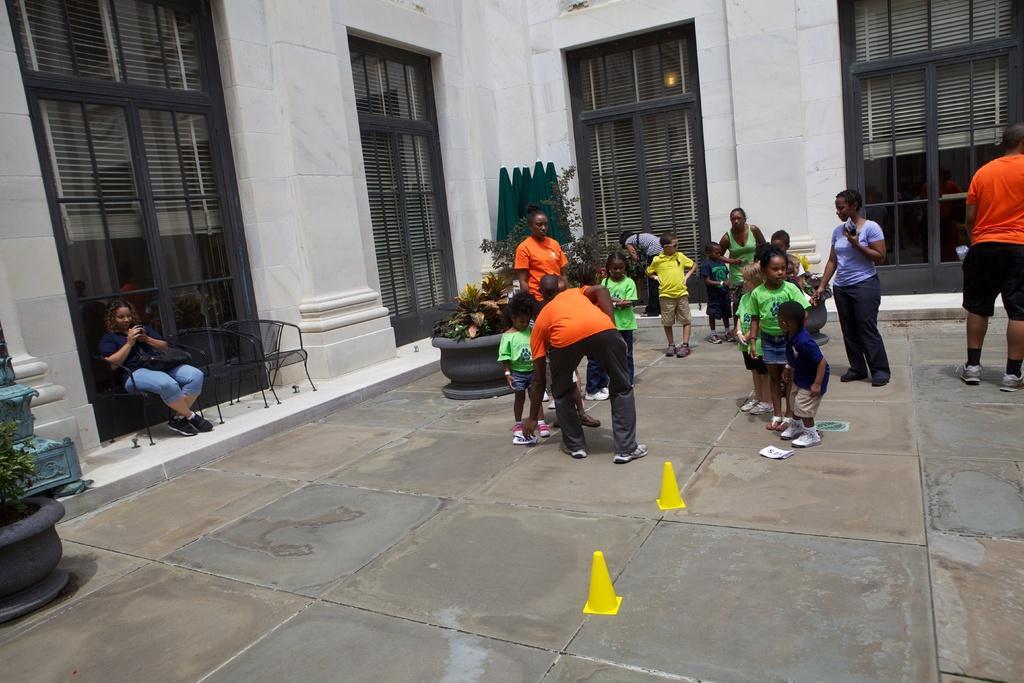Please provide a concise description of this image. In the picture we can see a surface and on it we can see some children and behind them we can see a wall with doors and near it we can see a man sitting on the chair. 